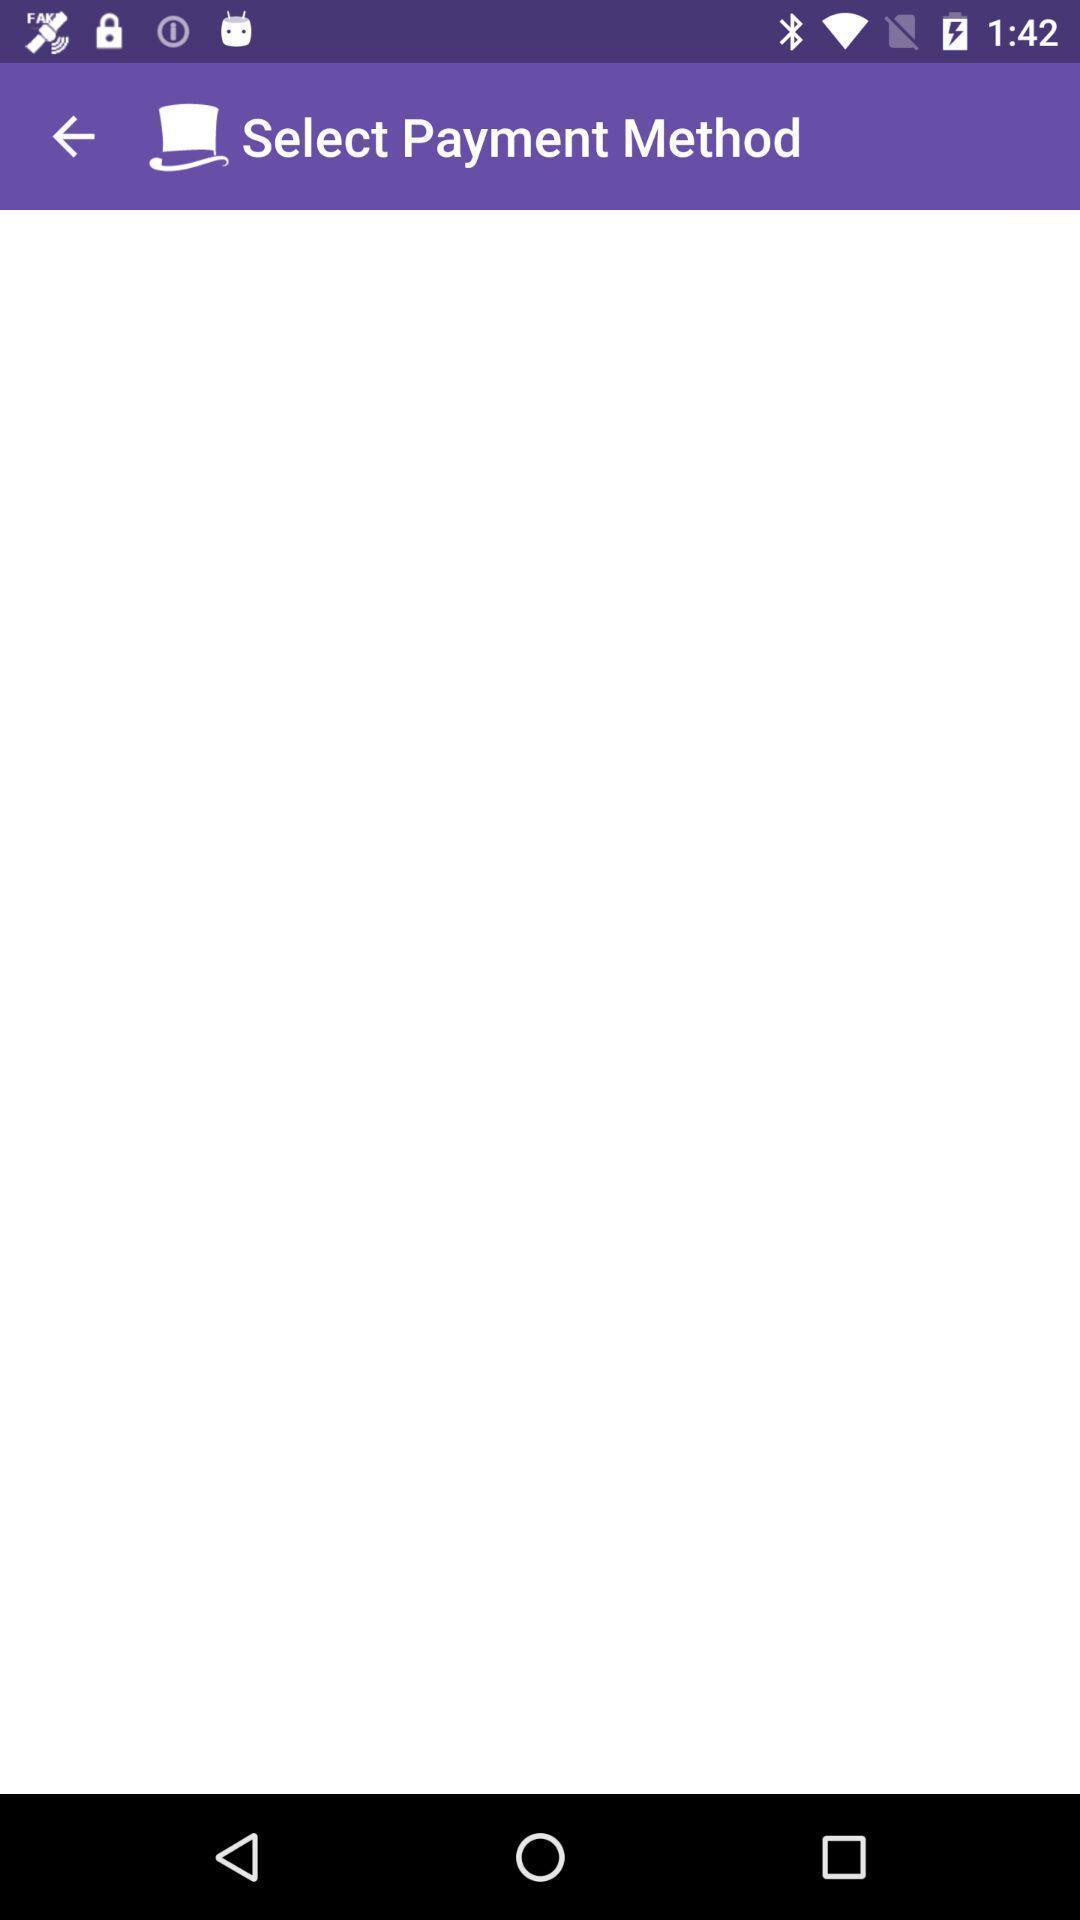Summarize the information in this screenshot. Page displaying the select payment method an a app. 